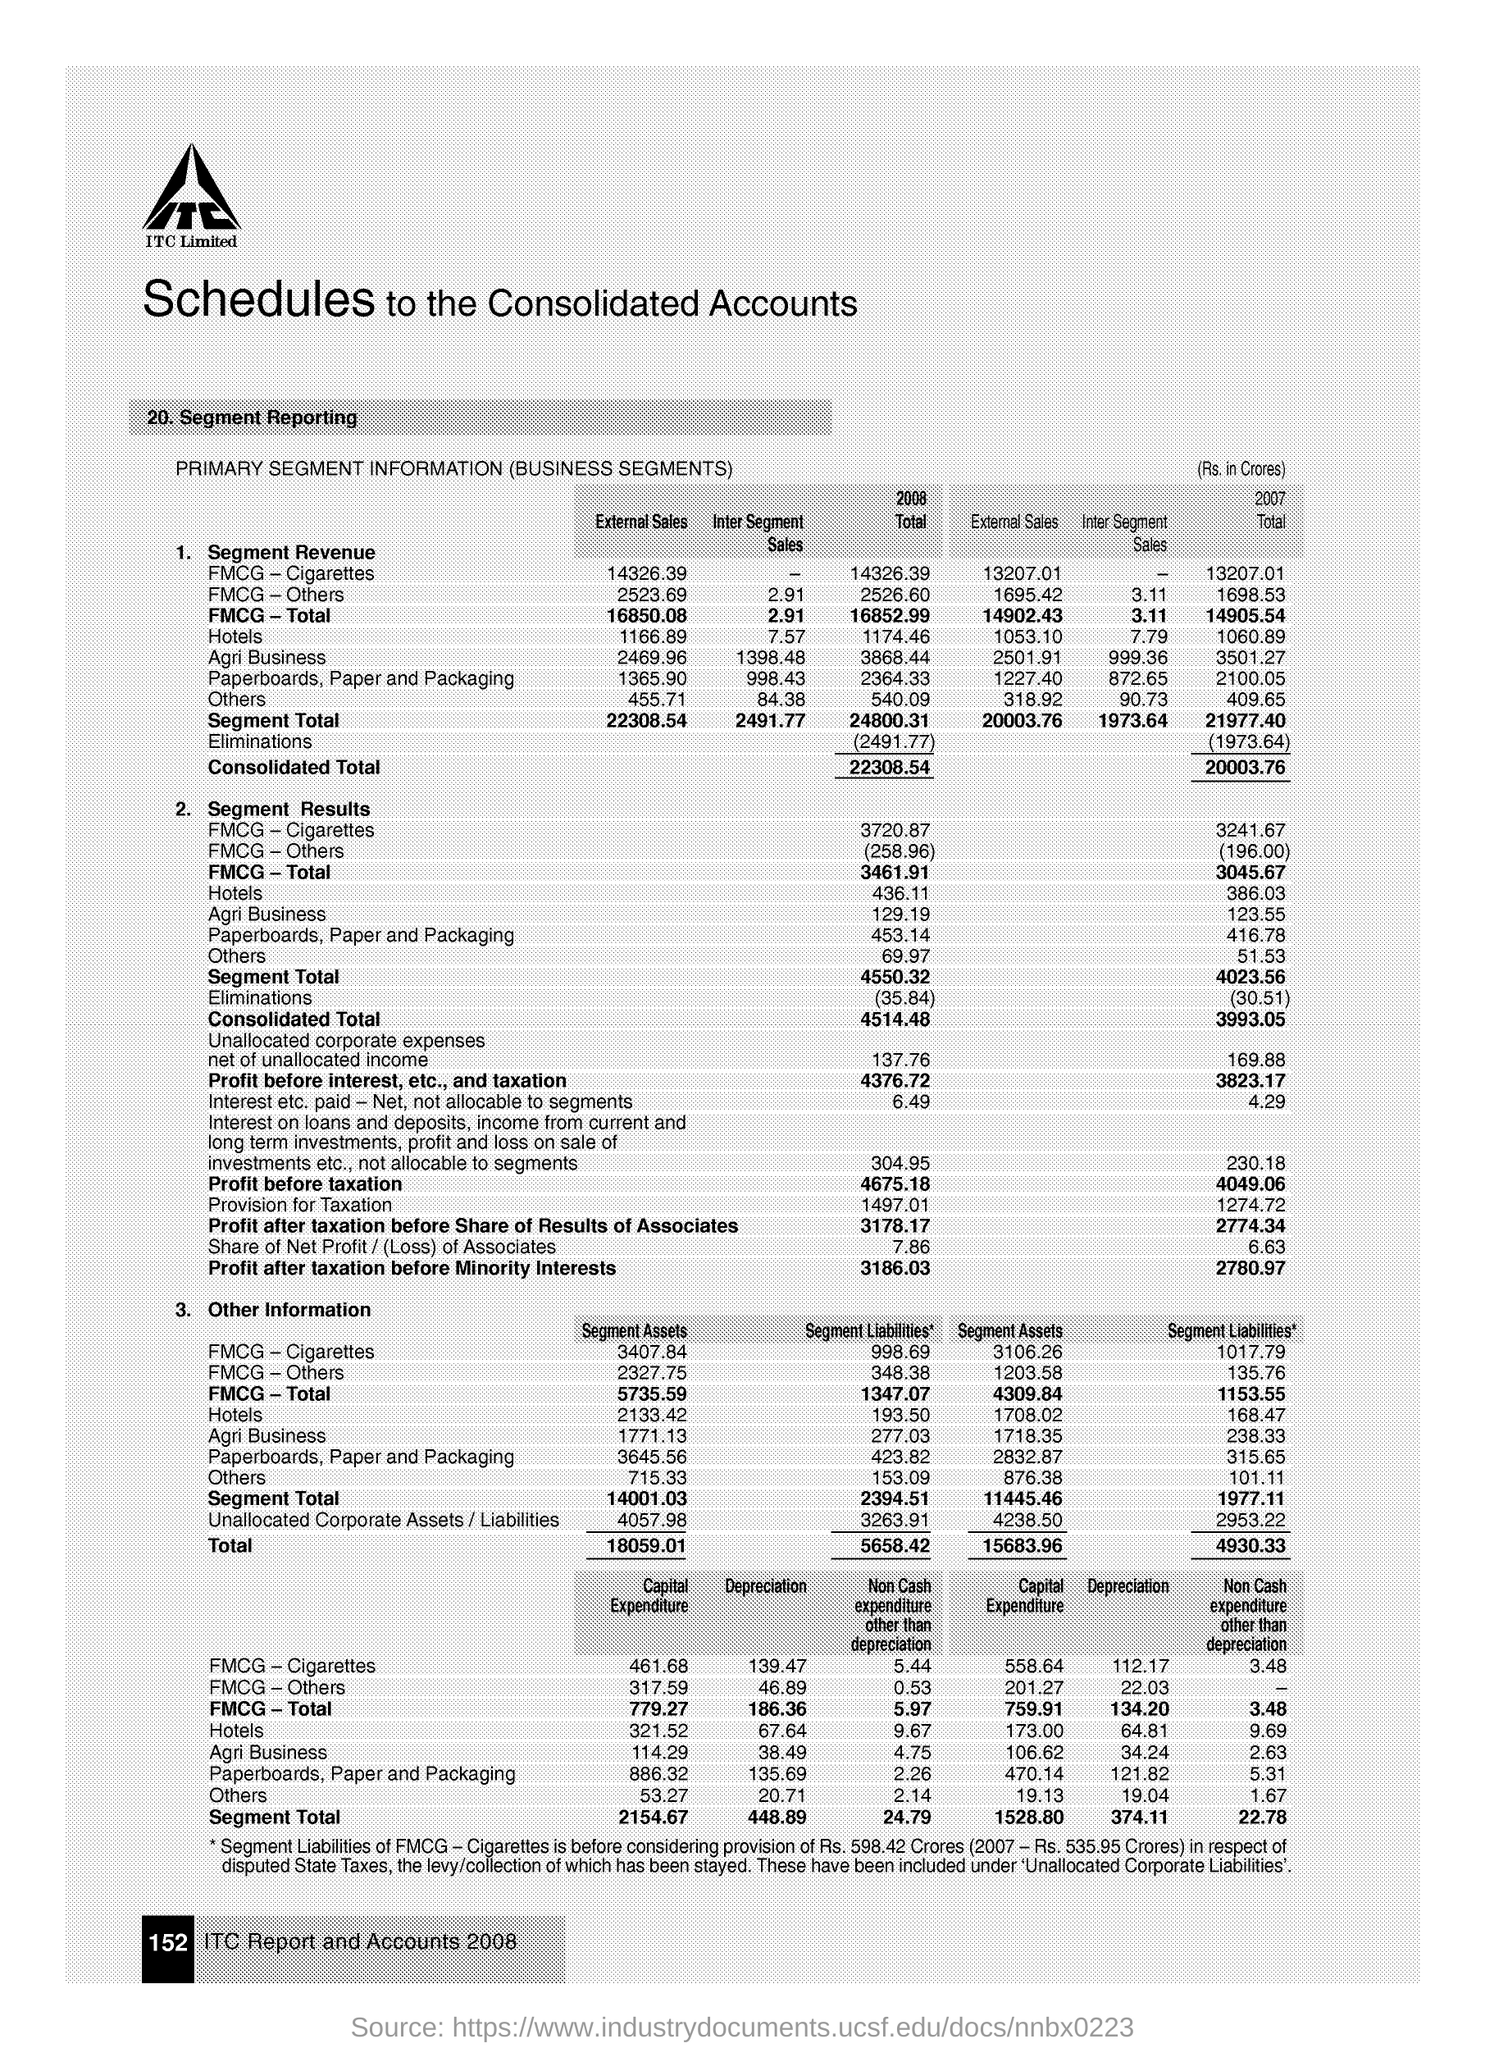What is the Profit after Taxation before Share of Results of Associates for 2008?
Make the answer very short. 3178.17. What is the Profit after Taxation before Minority Interests for 2008?
Keep it short and to the point. 3186.03. What is the Profit after Taxation before Share of Results of Associates for 2007?
Offer a terse response. 2774.34. What is the Profit after Taxation before Minority Interests for 2007?
Your response must be concise. 2780.97. What is the Profit before taxation for 2008?
Keep it short and to the point. 4675.18. What is the Profit before taxation for 2007?
Give a very brief answer. 4049.06. 